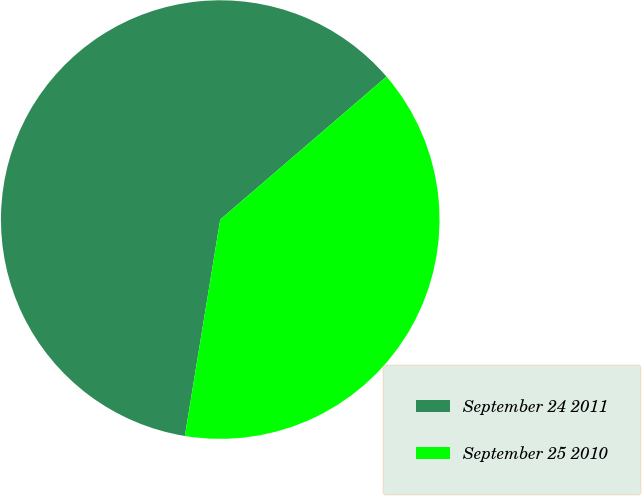Convert chart to OTSL. <chart><loc_0><loc_0><loc_500><loc_500><pie_chart><fcel>September 24 2011<fcel>September 25 2010<nl><fcel>61.12%<fcel>38.88%<nl></chart> 